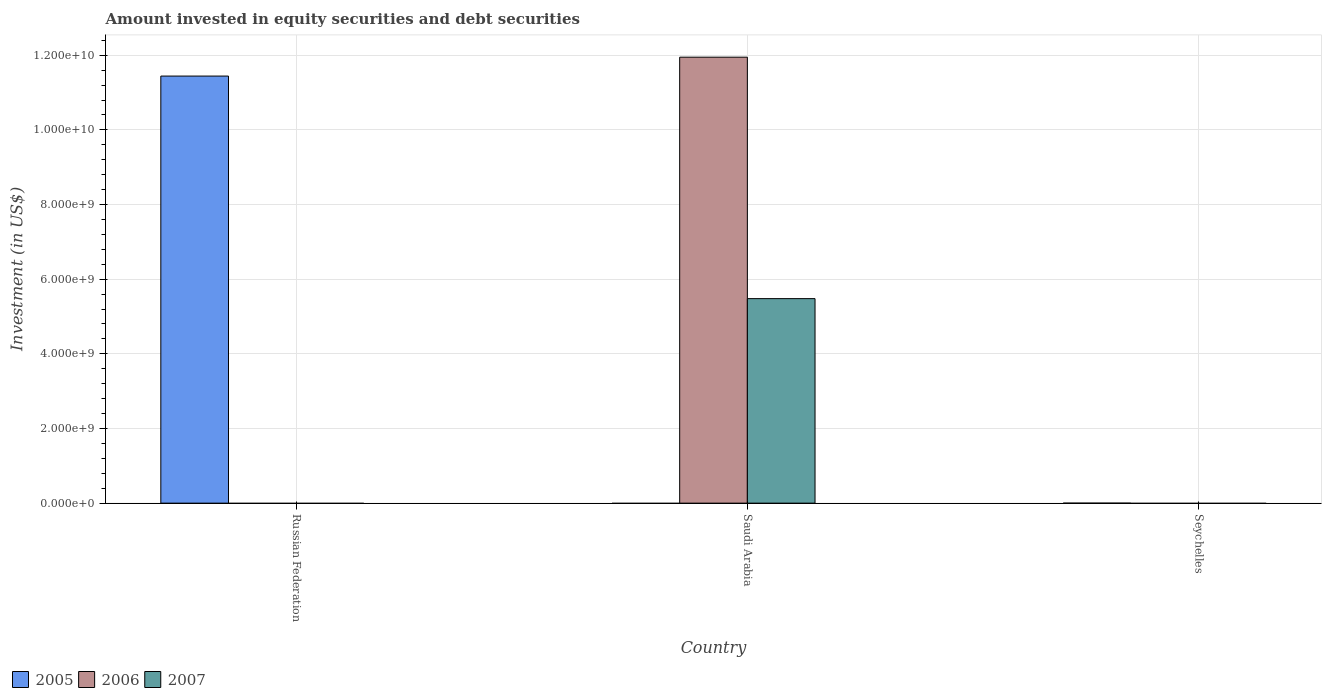How many different coloured bars are there?
Provide a succinct answer. 3. Are the number of bars per tick equal to the number of legend labels?
Give a very brief answer. No. How many bars are there on the 3rd tick from the left?
Your response must be concise. 0. How many bars are there on the 1st tick from the right?
Offer a terse response. 0. What is the label of the 2nd group of bars from the left?
Provide a short and direct response. Saudi Arabia. Across all countries, what is the maximum amount invested in equity securities and debt securities in 2006?
Give a very brief answer. 1.19e+1. Across all countries, what is the minimum amount invested in equity securities and debt securities in 2007?
Give a very brief answer. 0. In which country was the amount invested in equity securities and debt securities in 2005 maximum?
Provide a short and direct response. Russian Federation. What is the total amount invested in equity securities and debt securities in 2005 in the graph?
Give a very brief answer. 1.14e+1. What is the difference between the amount invested in equity securities and debt securities in 2007 in Seychelles and the amount invested in equity securities and debt securities in 2006 in Saudi Arabia?
Keep it short and to the point. -1.19e+1. What is the average amount invested in equity securities and debt securities in 2006 per country?
Ensure brevity in your answer.  3.98e+09. What is the difference between the amount invested in equity securities and debt securities of/in 2007 and amount invested in equity securities and debt securities of/in 2006 in Saudi Arabia?
Your answer should be compact. -6.47e+09. What is the difference between the highest and the lowest amount invested in equity securities and debt securities in 2007?
Keep it short and to the point. 5.48e+09. How many bars are there?
Your answer should be compact. 3. How many countries are there in the graph?
Provide a succinct answer. 3. What is the difference between two consecutive major ticks on the Y-axis?
Give a very brief answer. 2.00e+09. What is the title of the graph?
Give a very brief answer. Amount invested in equity securities and debt securities. Does "1987" appear as one of the legend labels in the graph?
Provide a short and direct response. No. What is the label or title of the Y-axis?
Provide a succinct answer. Investment (in US$). What is the Investment (in US$) of 2005 in Russian Federation?
Provide a short and direct response. 1.14e+1. What is the Investment (in US$) of 2006 in Saudi Arabia?
Make the answer very short. 1.19e+1. What is the Investment (in US$) in 2007 in Saudi Arabia?
Offer a very short reply. 5.48e+09. What is the Investment (in US$) of 2005 in Seychelles?
Keep it short and to the point. 0. What is the Investment (in US$) of 2007 in Seychelles?
Offer a terse response. 0. Across all countries, what is the maximum Investment (in US$) of 2005?
Your answer should be compact. 1.14e+1. Across all countries, what is the maximum Investment (in US$) of 2006?
Your answer should be compact. 1.19e+1. Across all countries, what is the maximum Investment (in US$) in 2007?
Offer a terse response. 5.48e+09. Across all countries, what is the minimum Investment (in US$) of 2007?
Offer a terse response. 0. What is the total Investment (in US$) in 2005 in the graph?
Offer a very short reply. 1.14e+1. What is the total Investment (in US$) of 2006 in the graph?
Your response must be concise. 1.19e+1. What is the total Investment (in US$) in 2007 in the graph?
Your response must be concise. 5.48e+09. What is the difference between the Investment (in US$) of 2005 in Russian Federation and the Investment (in US$) of 2006 in Saudi Arabia?
Your answer should be compact. -5.06e+08. What is the difference between the Investment (in US$) in 2005 in Russian Federation and the Investment (in US$) in 2007 in Saudi Arabia?
Make the answer very short. 5.96e+09. What is the average Investment (in US$) of 2005 per country?
Your response must be concise. 3.81e+09. What is the average Investment (in US$) in 2006 per country?
Provide a succinct answer. 3.98e+09. What is the average Investment (in US$) in 2007 per country?
Your response must be concise. 1.83e+09. What is the difference between the Investment (in US$) of 2006 and Investment (in US$) of 2007 in Saudi Arabia?
Provide a succinct answer. 6.47e+09. What is the difference between the highest and the lowest Investment (in US$) of 2005?
Your answer should be compact. 1.14e+1. What is the difference between the highest and the lowest Investment (in US$) in 2006?
Give a very brief answer. 1.19e+1. What is the difference between the highest and the lowest Investment (in US$) in 2007?
Your response must be concise. 5.48e+09. 